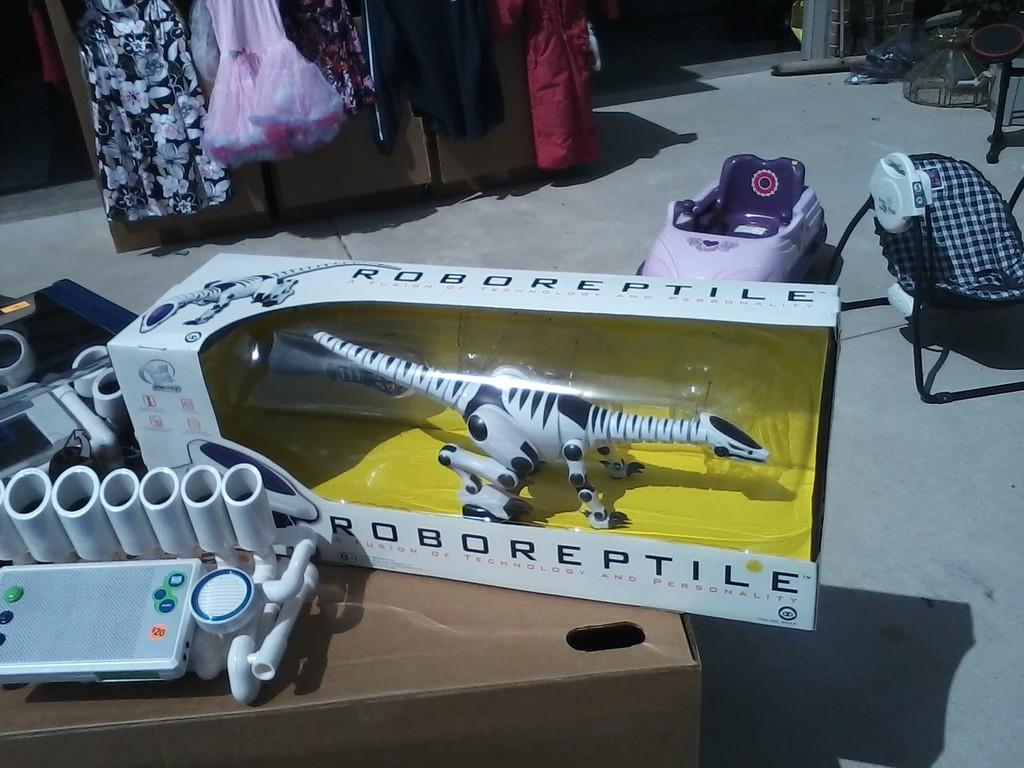What is the name of this toy robot?
Give a very brief answer. Roboreptile. 